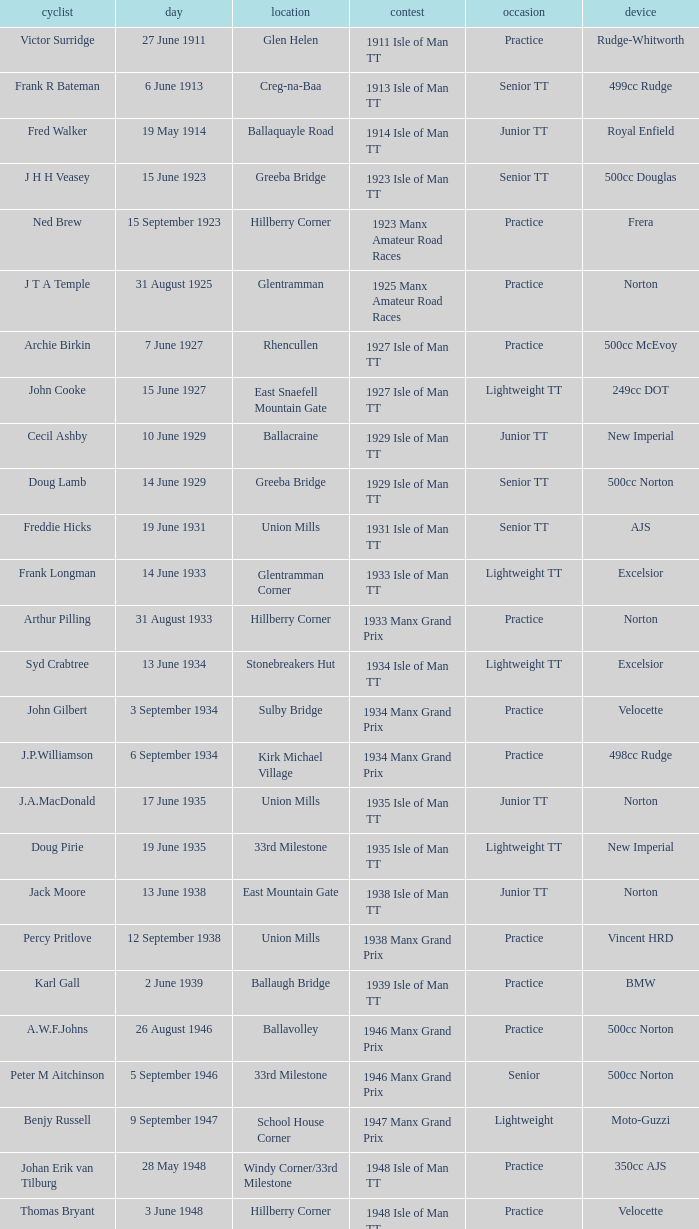Where was the 249cc Yamaha? Glentramman. 